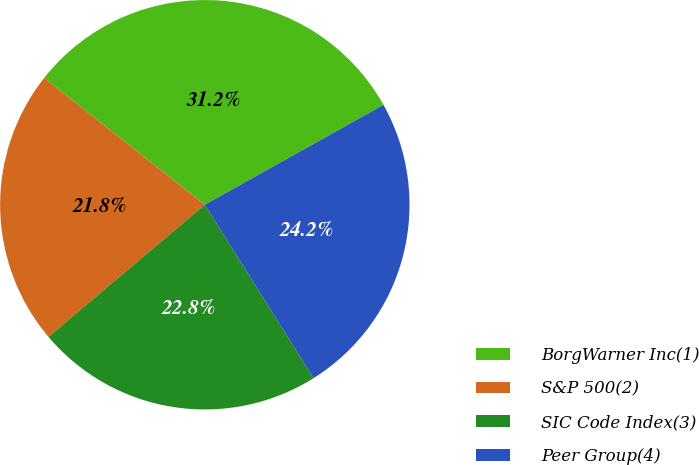Convert chart to OTSL. <chart><loc_0><loc_0><loc_500><loc_500><pie_chart><fcel>BorgWarner Inc(1)<fcel>S&P 500(2)<fcel>SIC Code Index(3)<fcel>Peer Group(4)<nl><fcel>31.25%<fcel>21.8%<fcel>22.75%<fcel>24.2%<nl></chart> 